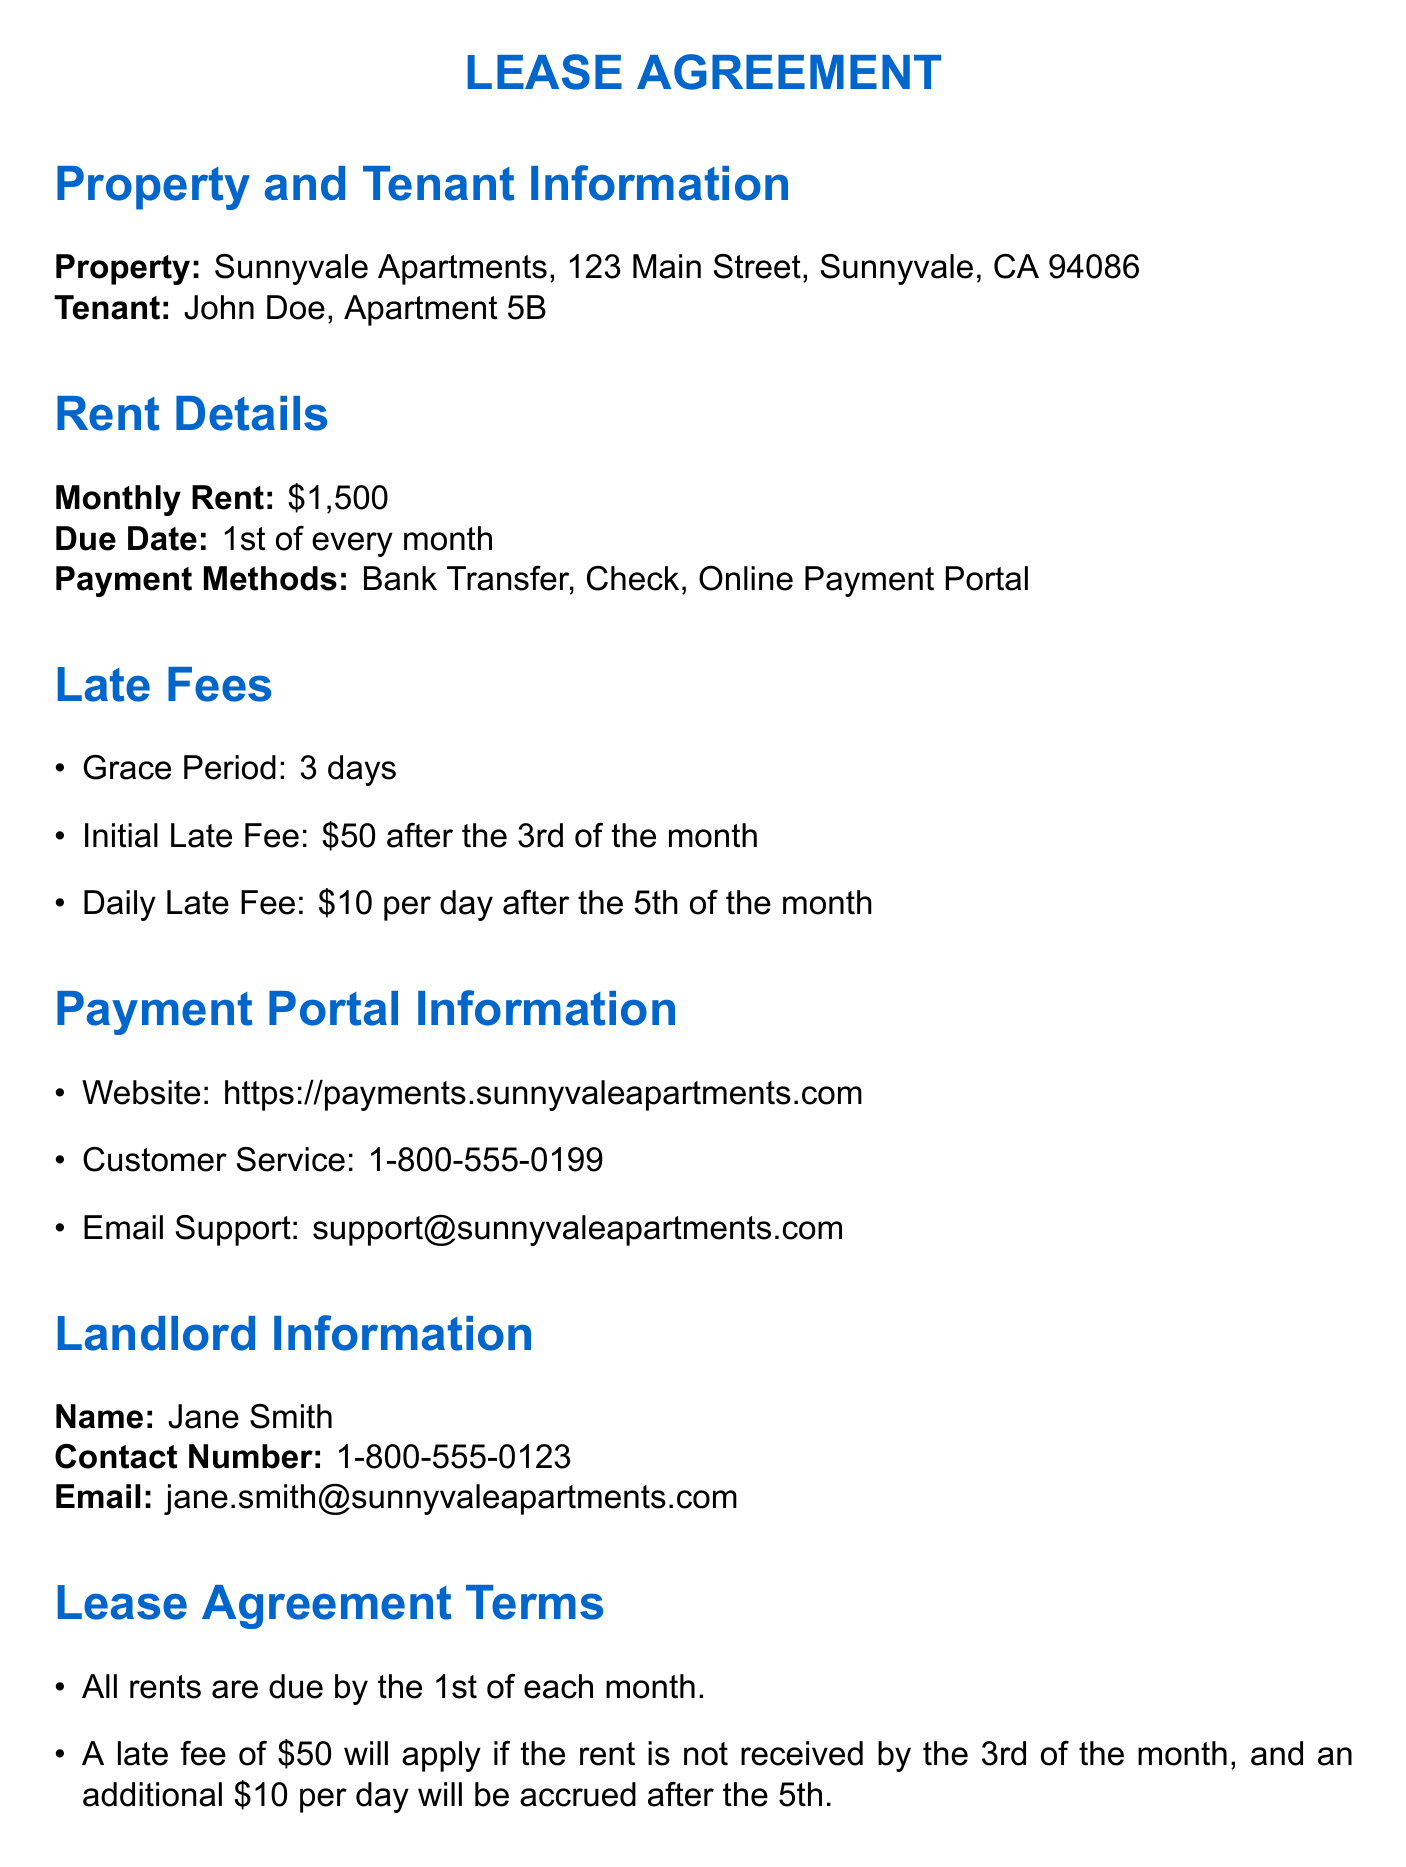What is the monthly rent? The monthly rent is explicitly stated in the document.
Answer: $1,500 Who is the tenant? The tenant's name is provided in the property and tenant information section.
Answer: John Doe What is the grace period for late rent payments? The document specifies the grace period duration in the late fees section.
Answer: 3 days What is the daily late fee after the 5th of the month? This amount is indicated in the late fees breakdown.
Answer: $10 What payment method is mentioned in the lease agreement? The document lists the payment methods available for rent.
Answer: Bank Transfer, Check, Online Payment Portal What happens if the rent is not received by the 3rd of the month? The initial late fee is outlined regarding late payments.
Answer: $50 When is rent due each month? The lease agreement states when rent is expected to be paid.
Answer: 1st of every month What is the landlord's name? The landlord's information section specifies the name.
Answer: Jane Smith How can a tenant contact customer service? The document provides a specific channel for customer service inquiries.
Answer: 1-800-555-0199 